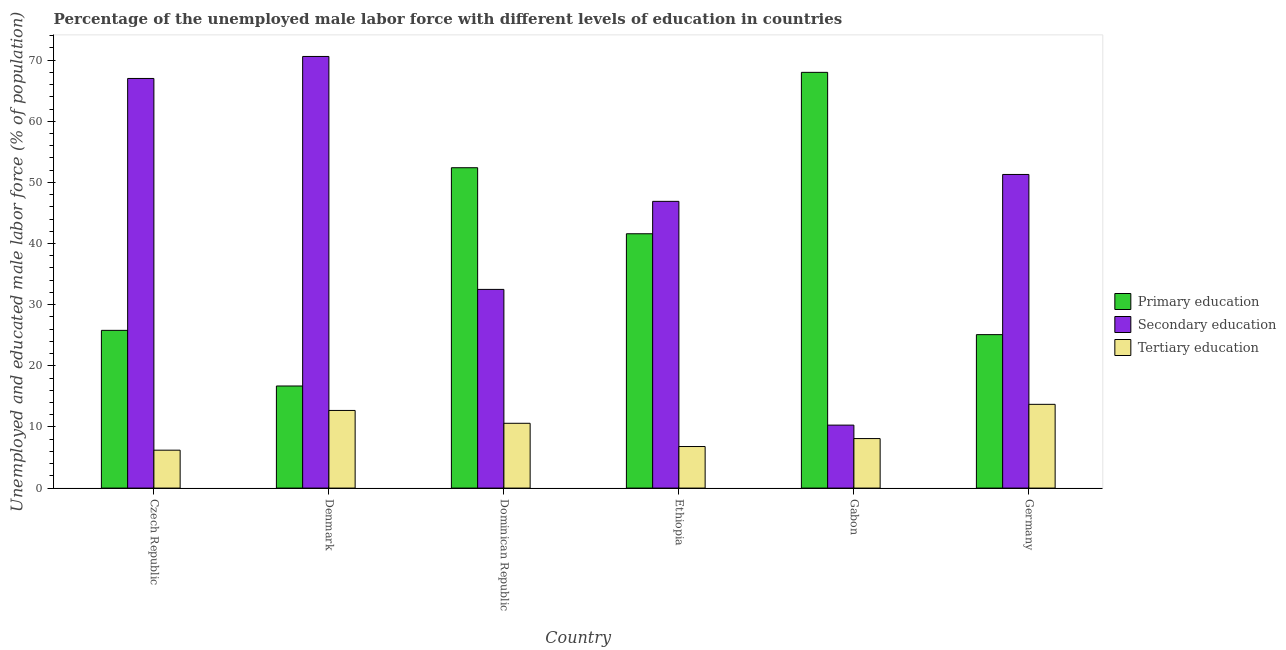How many different coloured bars are there?
Ensure brevity in your answer.  3. Are the number of bars per tick equal to the number of legend labels?
Provide a short and direct response. Yes. What is the label of the 5th group of bars from the left?
Provide a succinct answer. Gabon. In how many cases, is the number of bars for a given country not equal to the number of legend labels?
Offer a very short reply. 0. What is the percentage of male labor force who received secondary education in Czech Republic?
Offer a very short reply. 67. Across all countries, what is the maximum percentage of male labor force who received primary education?
Offer a terse response. 68. Across all countries, what is the minimum percentage of male labor force who received secondary education?
Ensure brevity in your answer.  10.3. In which country was the percentage of male labor force who received primary education maximum?
Your answer should be compact. Gabon. In which country was the percentage of male labor force who received tertiary education minimum?
Offer a terse response. Czech Republic. What is the total percentage of male labor force who received secondary education in the graph?
Keep it short and to the point. 278.6. What is the difference between the percentage of male labor force who received primary education in Dominican Republic and that in Ethiopia?
Your response must be concise. 10.8. What is the difference between the percentage of male labor force who received tertiary education in Germany and the percentage of male labor force who received secondary education in Ethiopia?
Keep it short and to the point. -33.2. What is the average percentage of male labor force who received secondary education per country?
Provide a succinct answer. 46.43. What is the difference between the percentage of male labor force who received primary education and percentage of male labor force who received secondary education in Czech Republic?
Offer a very short reply. -41.2. What is the ratio of the percentage of male labor force who received tertiary education in Czech Republic to that in Dominican Republic?
Provide a short and direct response. 0.58. Is the difference between the percentage of male labor force who received tertiary education in Gabon and Germany greater than the difference between the percentage of male labor force who received secondary education in Gabon and Germany?
Your answer should be compact. Yes. What is the difference between the highest and the second highest percentage of male labor force who received primary education?
Offer a very short reply. 15.6. What is the difference between the highest and the lowest percentage of male labor force who received tertiary education?
Your response must be concise. 7.5. Is the sum of the percentage of male labor force who received secondary education in Denmark and Germany greater than the maximum percentage of male labor force who received tertiary education across all countries?
Give a very brief answer. Yes. What does the 1st bar from the right in Ethiopia represents?
Make the answer very short. Tertiary education. How many bars are there?
Offer a terse response. 18. How many countries are there in the graph?
Offer a terse response. 6. What is the difference between two consecutive major ticks on the Y-axis?
Keep it short and to the point. 10. Are the values on the major ticks of Y-axis written in scientific E-notation?
Give a very brief answer. No. Does the graph contain any zero values?
Your response must be concise. No. Does the graph contain grids?
Offer a terse response. No. Where does the legend appear in the graph?
Your response must be concise. Center right. How are the legend labels stacked?
Give a very brief answer. Vertical. What is the title of the graph?
Your answer should be compact. Percentage of the unemployed male labor force with different levels of education in countries. What is the label or title of the Y-axis?
Keep it short and to the point. Unemployed and educated male labor force (% of population). What is the Unemployed and educated male labor force (% of population) in Primary education in Czech Republic?
Your response must be concise. 25.8. What is the Unemployed and educated male labor force (% of population) of Tertiary education in Czech Republic?
Your response must be concise. 6.2. What is the Unemployed and educated male labor force (% of population) in Primary education in Denmark?
Offer a very short reply. 16.7. What is the Unemployed and educated male labor force (% of population) of Secondary education in Denmark?
Your response must be concise. 70.6. What is the Unemployed and educated male labor force (% of population) of Tertiary education in Denmark?
Provide a succinct answer. 12.7. What is the Unemployed and educated male labor force (% of population) in Primary education in Dominican Republic?
Offer a very short reply. 52.4. What is the Unemployed and educated male labor force (% of population) in Secondary education in Dominican Republic?
Your answer should be compact. 32.5. What is the Unemployed and educated male labor force (% of population) of Tertiary education in Dominican Republic?
Offer a terse response. 10.6. What is the Unemployed and educated male labor force (% of population) in Primary education in Ethiopia?
Provide a short and direct response. 41.6. What is the Unemployed and educated male labor force (% of population) of Secondary education in Ethiopia?
Your answer should be very brief. 46.9. What is the Unemployed and educated male labor force (% of population) of Tertiary education in Ethiopia?
Make the answer very short. 6.8. What is the Unemployed and educated male labor force (% of population) in Secondary education in Gabon?
Offer a very short reply. 10.3. What is the Unemployed and educated male labor force (% of population) in Tertiary education in Gabon?
Your answer should be very brief. 8.1. What is the Unemployed and educated male labor force (% of population) in Primary education in Germany?
Keep it short and to the point. 25.1. What is the Unemployed and educated male labor force (% of population) of Secondary education in Germany?
Your answer should be compact. 51.3. What is the Unemployed and educated male labor force (% of population) of Tertiary education in Germany?
Your answer should be compact. 13.7. Across all countries, what is the maximum Unemployed and educated male labor force (% of population) in Secondary education?
Provide a succinct answer. 70.6. Across all countries, what is the maximum Unemployed and educated male labor force (% of population) in Tertiary education?
Offer a terse response. 13.7. Across all countries, what is the minimum Unemployed and educated male labor force (% of population) in Primary education?
Your answer should be very brief. 16.7. Across all countries, what is the minimum Unemployed and educated male labor force (% of population) in Secondary education?
Give a very brief answer. 10.3. Across all countries, what is the minimum Unemployed and educated male labor force (% of population) of Tertiary education?
Ensure brevity in your answer.  6.2. What is the total Unemployed and educated male labor force (% of population) in Primary education in the graph?
Keep it short and to the point. 229.6. What is the total Unemployed and educated male labor force (% of population) in Secondary education in the graph?
Provide a short and direct response. 278.6. What is the total Unemployed and educated male labor force (% of population) in Tertiary education in the graph?
Offer a terse response. 58.1. What is the difference between the Unemployed and educated male labor force (% of population) in Primary education in Czech Republic and that in Denmark?
Provide a succinct answer. 9.1. What is the difference between the Unemployed and educated male labor force (% of population) in Primary education in Czech Republic and that in Dominican Republic?
Offer a terse response. -26.6. What is the difference between the Unemployed and educated male labor force (% of population) of Secondary education in Czech Republic and that in Dominican Republic?
Ensure brevity in your answer.  34.5. What is the difference between the Unemployed and educated male labor force (% of population) of Tertiary education in Czech Republic and that in Dominican Republic?
Your answer should be very brief. -4.4. What is the difference between the Unemployed and educated male labor force (% of population) of Primary education in Czech Republic and that in Ethiopia?
Keep it short and to the point. -15.8. What is the difference between the Unemployed and educated male labor force (% of population) in Secondary education in Czech Republic and that in Ethiopia?
Make the answer very short. 20.1. What is the difference between the Unemployed and educated male labor force (% of population) of Tertiary education in Czech Republic and that in Ethiopia?
Give a very brief answer. -0.6. What is the difference between the Unemployed and educated male labor force (% of population) in Primary education in Czech Republic and that in Gabon?
Provide a short and direct response. -42.2. What is the difference between the Unemployed and educated male labor force (% of population) of Secondary education in Czech Republic and that in Gabon?
Your response must be concise. 56.7. What is the difference between the Unemployed and educated male labor force (% of population) in Secondary education in Czech Republic and that in Germany?
Offer a terse response. 15.7. What is the difference between the Unemployed and educated male labor force (% of population) of Tertiary education in Czech Republic and that in Germany?
Provide a short and direct response. -7.5. What is the difference between the Unemployed and educated male labor force (% of population) of Primary education in Denmark and that in Dominican Republic?
Provide a succinct answer. -35.7. What is the difference between the Unemployed and educated male labor force (% of population) in Secondary education in Denmark and that in Dominican Republic?
Make the answer very short. 38.1. What is the difference between the Unemployed and educated male labor force (% of population) of Tertiary education in Denmark and that in Dominican Republic?
Ensure brevity in your answer.  2.1. What is the difference between the Unemployed and educated male labor force (% of population) in Primary education in Denmark and that in Ethiopia?
Offer a terse response. -24.9. What is the difference between the Unemployed and educated male labor force (% of population) of Secondary education in Denmark and that in Ethiopia?
Ensure brevity in your answer.  23.7. What is the difference between the Unemployed and educated male labor force (% of population) in Primary education in Denmark and that in Gabon?
Ensure brevity in your answer.  -51.3. What is the difference between the Unemployed and educated male labor force (% of population) of Secondary education in Denmark and that in Gabon?
Ensure brevity in your answer.  60.3. What is the difference between the Unemployed and educated male labor force (% of population) in Tertiary education in Denmark and that in Gabon?
Ensure brevity in your answer.  4.6. What is the difference between the Unemployed and educated male labor force (% of population) of Primary education in Denmark and that in Germany?
Your response must be concise. -8.4. What is the difference between the Unemployed and educated male labor force (% of population) in Secondary education in Denmark and that in Germany?
Keep it short and to the point. 19.3. What is the difference between the Unemployed and educated male labor force (% of population) in Tertiary education in Denmark and that in Germany?
Offer a very short reply. -1. What is the difference between the Unemployed and educated male labor force (% of population) in Primary education in Dominican Republic and that in Ethiopia?
Give a very brief answer. 10.8. What is the difference between the Unemployed and educated male labor force (% of population) in Secondary education in Dominican Republic and that in Ethiopia?
Your response must be concise. -14.4. What is the difference between the Unemployed and educated male labor force (% of population) of Tertiary education in Dominican Republic and that in Ethiopia?
Ensure brevity in your answer.  3.8. What is the difference between the Unemployed and educated male labor force (% of population) in Primary education in Dominican Republic and that in Gabon?
Provide a short and direct response. -15.6. What is the difference between the Unemployed and educated male labor force (% of population) of Primary education in Dominican Republic and that in Germany?
Provide a short and direct response. 27.3. What is the difference between the Unemployed and educated male labor force (% of population) in Secondary education in Dominican Republic and that in Germany?
Ensure brevity in your answer.  -18.8. What is the difference between the Unemployed and educated male labor force (% of population) of Tertiary education in Dominican Republic and that in Germany?
Ensure brevity in your answer.  -3.1. What is the difference between the Unemployed and educated male labor force (% of population) of Primary education in Ethiopia and that in Gabon?
Make the answer very short. -26.4. What is the difference between the Unemployed and educated male labor force (% of population) in Secondary education in Ethiopia and that in Gabon?
Offer a very short reply. 36.6. What is the difference between the Unemployed and educated male labor force (% of population) in Tertiary education in Ethiopia and that in Gabon?
Your answer should be compact. -1.3. What is the difference between the Unemployed and educated male labor force (% of population) in Primary education in Ethiopia and that in Germany?
Make the answer very short. 16.5. What is the difference between the Unemployed and educated male labor force (% of population) of Tertiary education in Ethiopia and that in Germany?
Ensure brevity in your answer.  -6.9. What is the difference between the Unemployed and educated male labor force (% of population) of Primary education in Gabon and that in Germany?
Your answer should be compact. 42.9. What is the difference between the Unemployed and educated male labor force (% of population) in Secondary education in Gabon and that in Germany?
Provide a short and direct response. -41. What is the difference between the Unemployed and educated male labor force (% of population) of Tertiary education in Gabon and that in Germany?
Your answer should be compact. -5.6. What is the difference between the Unemployed and educated male labor force (% of population) in Primary education in Czech Republic and the Unemployed and educated male labor force (% of population) in Secondary education in Denmark?
Provide a succinct answer. -44.8. What is the difference between the Unemployed and educated male labor force (% of population) in Secondary education in Czech Republic and the Unemployed and educated male labor force (% of population) in Tertiary education in Denmark?
Your answer should be compact. 54.3. What is the difference between the Unemployed and educated male labor force (% of population) in Primary education in Czech Republic and the Unemployed and educated male labor force (% of population) in Secondary education in Dominican Republic?
Give a very brief answer. -6.7. What is the difference between the Unemployed and educated male labor force (% of population) of Primary education in Czech Republic and the Unemployed and educated male labor force (% of population) of Tertiary education in Dominican Republic?
Your answer should be very brief. 15.2. What is the difference between the Unemployed and educated male labor force (% of population) in Secondary education in Czech Republic and the Unemployed and educated male labor force (% of population) in Tertiary education in Dominican Republic?
Your response must be concise. 56.4. What is the difference between the Unemployed and educated male labor force (% of population) of Primary education in Czech Republic and the Unemployed and educated male labor force (% of population) of Secondary education in Ethiopia?
Provide a short and direct response. -21.1. What is the difference between the Unemployed and educated male labor force (% of population) in Primary education in Czech Republic and the Unemployed and educated male labor force (% of population) in Tertiary education in Ethiopia?
Ensure brevity in your answer.  19. What is the difference between the Unemployed and educated male labor force (% of population) of Secondary education in Czech Republic and the Unemployed and educated male labor force (% of population) of Tertiary education in Ethiopia?
Ensure brevity in your answer.  60.2. What is the difference between the Unemployed and educated male labor force (% of population) in Secondary education in Czech Republic and the Unemployed and educated male labor force (% of population) in Tertiary education in Gabon?
Make the answer very short. 58.9. What is the difference between the Unemployed and educated male labor force (% of population) of Primary education in Czech Republic and the Unemployed and educated male labor force (% of population) of Secondary education in Germany?
Offer a terse response. -25.5. What is the difference between the Unemployed and educated male labor force (% of population) in Secondary education in Czech Republic and the Unemployed and educated male labor force (% of population) in Tertiary education in Germany?
Keep it short and to the point. 53.3. What is the difference between the Unemployed and educated male labor force (% of population) of Primary education in Denmark and the Unemployed and educated male labor force (% of population) of Secondary education in Dominican Republic?
Your answer should be very brief. -15.8. What is the difference between the Unemployed and educated male labor force (% of population) of Primary education in Denmark and the Unemployed and educated male labor force (% of population) of Tertiary education in Dominican Republic?
Provide a succinct answer. 6.1. What is the difference between the Unemployed and educated male labor force (% of population) of Secondary education in Denmark and the Unemployed and educated male labor force (% of population) of Tertiary education in Dominican Republic?
Your answer should be very brief. 60. What is the difference between the Unemployed and educated male labor force (% of population) of Primary education in Denmark and the Unemployed and educated male labor force (% of population) of Secondary education in Ethiopia?
Provide a short and direct response. -30.2. What is the difference between the Unemployed and educated male labor force (% of population) in Primary education in Denmark and the Unemployed and educated male labor force (% of population) in Tertiary education in Ethiopia?
Offer a terse response. 9.9. What is the difference between the Unemployed and educated male labor force (% of population) in Secondary education in Denmark and the Unemployed and educated male labor force (% of population) in Tertiary education in Ethiopia?
Your answer should be very brief. 63.8. What is the difference between the Unemployed and educated male labor force (% of population) of Primary education in Denmark and the Unemployed and educated male labor force (% of population) of Tertiary education in Gabon?
Give a very brief answer. 8.6. What is the difference between the Unemployed and educated male labor force (% of population) in Secondary education in Denmark and the Unemployed and educated male labor force (% of population) in Tertiary education in Gabon?
Your answer should be compact. 62.5. What is the difference between the Unemployed and educated male labor force (% of population) of Primary education in Denmark and the Unemployed and educated male labor force (% of population) of Secondary education in Germany?
Your response must be concise. -34.6. What is the difference between the Unemployed and educated male labor force (% of population) of Secondary education in Denmark and the Unemployed and educated male labor force (% of population) of Tertiary education in Germany?
Ensure brevity in your answer.  56.9. What is the difference between the Unemployed and educated male labor force (% of population) in Primary education in Dominican Republic and the Unemployed and educated male labor force (% of population) in Secondary education in Ethiopia?
Keep it short and to the point. 5.5. What is the difference between the Unemployed and educated male labor force (% of population) in Primary education in Dominican Republic and the Unemployed and educated male labor force (% of population) in Tertiary education in Ethiopia?
Provide a succinct answer. 45.6. What is the difference between the Unemployed and educated male labor force (% of population) in Secondary education in Dominican Republic and the Unemployed and educated male labor force (% of population) in Tertiary education in Ethiopia?
Keep it short and to the point. 25.7. What is the difference between the Unemployed and educated male labor force (% of population) in Primary education in Dominican Republic and the Unemployed and educated male labor force (% of population) in Secondary education in Gabon?
Your answer should be compact. 42.1. What is the difference between the Unemployed and educated male labor force (% of population) of Primary education in Dominican Republic and the Unemployed and educated male labor force (% of population) of Tertiary education in Gabon?
Offer a terse response. 44.3. What is the difference between the Unemployed and educated male labor force (% of population) in Secondary education in Dominican Republic and the Unemployed and educated male labor force (% of population) in Tertiary education in Gabon?
Ensure brevity in your answer.  24.4. What is the difference between the Unemployed and educated male labor force (% of population) of Primary education in Dominican Republic and the Unemployed and educated male labor force (% of population) of Secondary education in Germany?
Keep it short and to the point. 1.1. What is the difference between the Unemployed and educated male labor force (% of population) of Primary education in Dominican Republic and the Unemployed and educated male labor force (% of population) of Tertiary education in Germany?
Provide a short and direct response. 38.7. What is the difference between the Unemployed and educated male labor force (% of population) in Secondary education in Dominican Republic and the Unemployed and educated male labor force (% of population) in Tertiary education in Germany?
Offer a terse response. 18.8. What is the difference between the Unemployed and educated male labor force (% of population) of Primary education in Ethiopia and the Unemployed and educated male labor force (% of population) of Secondary education in Gabon?
Make the answer very short. 31.3. What is the difference between the Unemployed and educated male labor force (% of population) of Primary education in Ethiopia and the Unemployed and educated male labor force (% of population) of Tertiary education in Gabon?
Your answer should be very brief. 33.5. What is the difference between the Unemployed and educated male labor force (% of population) of Secondary education in Ethiopia and the Unemployed and educated male labor force (% of population) of Tertiary education in Gabon?
Your answer should be very brief. 38.8. What is the difference between the Unemployed and educated male labor force (% of population) in Primary education in Ethiopia and the Unemployed and educated male labor force (% of population) in Tertiary education in Germany?
Your answer should be very brief. 27.9. What is the difference between the Unemployed and educated male labor force (% of population) of Secondary education in Ethiopia and the Unemployed and educated male labor force (% of population) of Tertiary education in Germany?
Ensure brevity in your answer.  33.2. What is the difference between the Unemployed and educated male labor force (% of population) in Primary education in Gabon and the Unemployed and educated male labor force (% of population) in Secondary education in Germany?
Your answer should be compact. 16.7. What is the difference between the Unemployed and educated male labor force (% of population) in Primary education in Gabon and the Unemployed and educated male labor force (% of population) in Tertiary education in Germany?
Your answer should be very brief. 54.3. What is the average Unemployed and educated male labor force (% of population) of Primary education per country?
Make the answer very short. 38.27. What is the average Unemployed and educated male labor force (% of population) in Secondary education per country?
Your answer should be very brief. 46.43. What is the average Unemployed and educated male labor force (% of population) in Tertiary education per country?
Keep it short and to the point. 9.68. What is the difference between the Unemployed and educated male labor force (% of population) in Primary education and Unemployed and educated male labor force (% of population) in Secondary education in Czech Republic?
Keep it short and to the point. -41.2. What is the difference between the Unemployed and educated male labor force (% of population) of Primary education and Unemployed and educated male labor force (% of population) of Tertiary education in Czech Republic?
Keep it short and to the point. 19.6. What is the difference between the Unemployed and educated male labor force (% of population) of Secondary education and Unemployed and educated male labor force (% of population) of Tertiary education in Czech Republic?
Provide a succinct answer. 60.8. What is the difference between the Unemployed and educated male labor force (% of population) of Primary education and Unemployed and educated male labor force (% of population) of Secondary education in Denmark?
Your answer should be compact. -53.9. What is the difference between the Unemployed and educated male labor force (% of population) in Secondary education and Unemployed and educated male labor force (% of population) in Tertiary education in Denmark?
Your answer should be compact. 57.9. What is the difference between the Unemployed and educated male labor force (% of population) in Primary education and Unemployed and educated male labor force (% of population) in Secondary education in Dominican Republic?
Offer a very short reply. 19.9. What is the difference between the Unemployed and educated male labor force (% of population) in Primary education and Unemployed and educated male labor force (% of population) in Tertiary education in Dominican Republic?
Your response must be concise. 41.8. What is the difference between the Unemployed and educated male labor force (% of population) of Secondary education and Unemployed and educated male labor force (% of population) of Tertiary education in Dominican Republic?
Give a very brief answer. 21.9. What is the difference between the Unemployed and educated male labor force (% of population) of Primary education and Unemployed and educated male labor force (% of population) of Secondary education in Ethiopia?
Provide a short and direct response. -5.3. What is the difference between the Unemployed and educated male labor force (% of population) in Primary education and Unemployed and educated male labor force (% of population) in Tertiary education in Ethiopia?
Offer a very short reply. 34.8. What is the difference between the Unemployed and educated male labor force (% of population) in Secondary education and Unemployed and educated male labor force (% of population) in Tertiary education in Ethiopia?
Your response must be concise. 40.1. What is the difference between the Unemployed and educated male labor force (% of population) of Primary education and Unemployed and educated male labor force (% of population) of Secondary education in Gabon?
Offer a very short reply. 57.7. What is the difference between the Unemployed and educated male labor force (% of population) in Primary education and Unemployed and educated male labor force (% of population) in Tertiary education in Gabon?
Keep it short and to the point. 59.9. What is the difference between the Unemployed and educated male labor force (% of population) in Primary education and Unemployed and educated male labor force (% of population) in Secondary education in Germany?
Your answer should be compact. -26.2. What is the difference between the Unemployed and educated male labor force (% of population) of Secondary education and Unemployed and educated male labor force (% of population) of Tertiary education in Germany?
Offer a very short reply. 37.6. What is the ratio of the Unemployed and educated male labor force (% of population) in Primary education in Czech Republic to that in Denmark?
Your answer should be compact. 1.54. What is the ratio of the Unemployed and educated male labor force (% of population) in Secondary education in Czech Republic to that in Denmark?
Your answer should be compact. 0.95. What is the ratio of the Unemployed and educated male labor force (% of population) of Tertiary education in Czech Republic to that in Denmark?
Give a very brief answer. 0.49. What is the ratio of the Unemployed and educated male labor force (% of population) of Primary education in Czech Republic to that in Dominican Republic?
Give a very brief answer. 0.49. What is the ratio of the Unemployed and educated male labor force (% of population) of Secondary education in Czech Republic to that in Dominican Republic?
Your answer should be compact. 2.06. What is the ratio of the Unemployed and educated male labor force (% of population) of Tertiary education in Czech Republic to that in Dominican Republic?
Your response must be concise. 0.58. What is the ratio of the Unemployed and educated male labor force (% of population) in Primary education in Czech Republic to that in Ethiopia?
Your answer should be compact. 0.62. What is the ratio of the Unemployed and educated male labor force (% of population) in Secondary education in Czech Republic to that in Ethiopia?
Your response must be concise. 1.43. What is the ratio of the Unemployed and educated male labor force (% of population) in Tertiary education in Czech Republic to that in Ethiopia?
Provide a succinct answer. 0.91. What is the ratio of the Unemployed and educated male labor force (% of population) of Primary education in Czech Republic to that in Gabon?
Your response must be concise. 0.38. What is the ratio of the Unemployed and educated male labor force (% of population) of Secondary education in Czech Republic to that in Gabon?
Ensure brevity in your answer.  6.5. What is the ratio of the Unemployed and educated male labor force (% of population) in Tertiary education in Czech Republic to that in Gabon?
Your answer should be compact. 0.77. What is the ratio of the Unemployed and educated male labor force (% of population) in Primary education in Czech Republic to that in Germany?
Offer a terse response. 1.03. What is the ratio of the Unemployed and educated male labor force (% of population) in Secondary education in Czech Republic to that in Germany?
Make the answer very short. 1.31. What is the ratio of the Unemployed and educated male labor force (% of population) in Tertiary education in Czech Republic to that in Germany?
Offer a very short reply. 0.45. What is the ratio of the Unemployed and educated male labor force (% of population) of Primary education in Denmark to that in Dominican Republic?
Provide a short and direct response. 0.32. What is the ratio of the Unemployed and educated male labor force (% of population) of Secondary education in Denmark to that in Dominican Republic?
Provide a succinct answer. 2.17. What is the ratio of the Unemployed and educated male labor force (% of population) of Tertiary education in Denmark to that in Dominican Republic?
Keep it short and to the point. 1.2. What is the ratio of the Unemployed and educated male labor force (% of population) of Primary education in Denmark to that in Ethiopia?
Ensure brevity in your answer.  0.4. What is the ratio of the Unemployed and educated male labor force (% of population) in Secondary education in Denmark to that in Ethiopia?
Offer a terse response. 1.51. What is the ratio of the Unemployed and educated male labor force (% of population) of Tertiary education in Denmark to that in Ethiopia?
Ensure brevity in your answer.  1.87. What is the ratio of the Unemployed and educated male labor force (% of population) in Primary education in Denmark to that in Gabon?
Ensure brevity in your answer.  0.25. What is the ratio of the Unemployed and educated male labor force (% of population) in Secondary education in Denmark to that in Gabon?
Ensure brevity in your answer.  6.85. What is the ratio of the Unemployed and educated male labor force (% of population) of Tertiary education in Denmark to that in Gabon?
Provide a short and direct response. 1.57. What is the ratio of the Unemployed and educated male labor force (% of population) in Primary education in Denmark to that in Germany?
Give a very brief answer. 0.67. What is the ratio of the Unemployed and educated male labor force (% of population) in Secondary education in Denmark to that in Germany?
Provide a short and direct response. 1.38. What is the ratio of the Unemployed and educated male labor force (% of population) in Tertiary education in Denmark to that in Germany?
Give a very brief answer. 0.93. What is the ratio of the Unemployed and educated male labor force (% of population) of Primary education in Dominican Republic to that in Ethiopia?
Keep it short and to the point. 1.26. What is the ratio of the Unemployed and educated male labor force (% of population) of Secondary education in Dominican Republic to that in Ethiopia?
Offer a terse response. 0.69. What is the ratio of the Unemployed and educated male labor force (% of population) in Tertiary education in Dominican Republic to that in Ethiopia?
Make the answer very short. 1.56. What is the ratio of the Unemployed and educated male labor force (% of population) of Primary education in Dominican Republic to that in Gabon?
Ensure brevity in your answer.  0.77. What is the ratio of the Unemployed and educated male labor force (% of population) of Secondary education in Dominican Republic to that in Gabon?
Make the answer very short. 3.16. What is the ratio of the Unemployed and educated male labor force (% of population) of Tertiary education in Dominican Republic to that in Gabon?
Your answer should be very brief. 1.31. What is the ratio of the Unemployed and educated male labor force (% of population) of Primary education in Dominican Republic to that in Germany?
Keep it short and to the point. 2.09. What is the ratio of the Unemployed and educated male labor force (% of population) in Secondary education in Dominican Republic to that in Germany?
Provide a succinct answer. 0.63. What is the ratio of the Unemployed and educated male labor force (% of population) in Tertiary education in Dominican Republic to that in Germany?
Provide a succinct answer. 0.77. What is the ratio of the Unemployed and educated male labor force (% of population) in Primary education in Ethiopia to that in Gabon?
Your response must be concise. 0.61. What is the ratio of the Unemployed and educated male labor force (% of population) in Secondary education in Ethiopia to that in Gabon?
Provide a succinct answer. 4.55. What is the ratio of the Unemployed and educated male labor force (% of population) of Tertiary education in Ethiopia to that in Gabon?
Provide a succinct answer. 0.84. What is the ratio of the Unemployed and educated male labor force (% of population) in Primary education in Ethiopia to that in Germany?
Provide a succinct answer. 1.66. What is the ratio of the Unemployed and educated male labor force (% of population) of Secondary education in Ethiopia to that in Germany?
Offer a very short reply. 0.91. What is the ratio of the Unemployed and educated male labor force (% of population) of Tertiary education in Ethiopia to that in Germany?
Provide a short and direct response. 0.5. What is the ratio of the Unemployed and educated male labor force (% of population) of Primary education in Gabon to that in Germany?
Give a very brief answer. 2.71. What is the ratio of the Unemployed and educated male labor force (% of population) of Secondary education in Gabon to that in Germany?
Your response must be concise. 0.2. What is the ratio of the Unemployed and educated male labor force (% of population) in Tertiary education in Gabon to that in Germany?
Your answer should be very brief. 0.59. What is the difference between the highest and the second highest Unemployed and educated male labor force (% of population) in Secondary education?
Give a very brief answer. 3.6. What is the difference between the highest and the lowest Unemployed and educated male labor force (% of population) in Primary education?
Your answer should be compact. 51.3. What is the difference between the highest and the lowest Unemployed and educated male labor force (% of population) of Secondary education?
Ensure brevity in your answer.  60.3. 